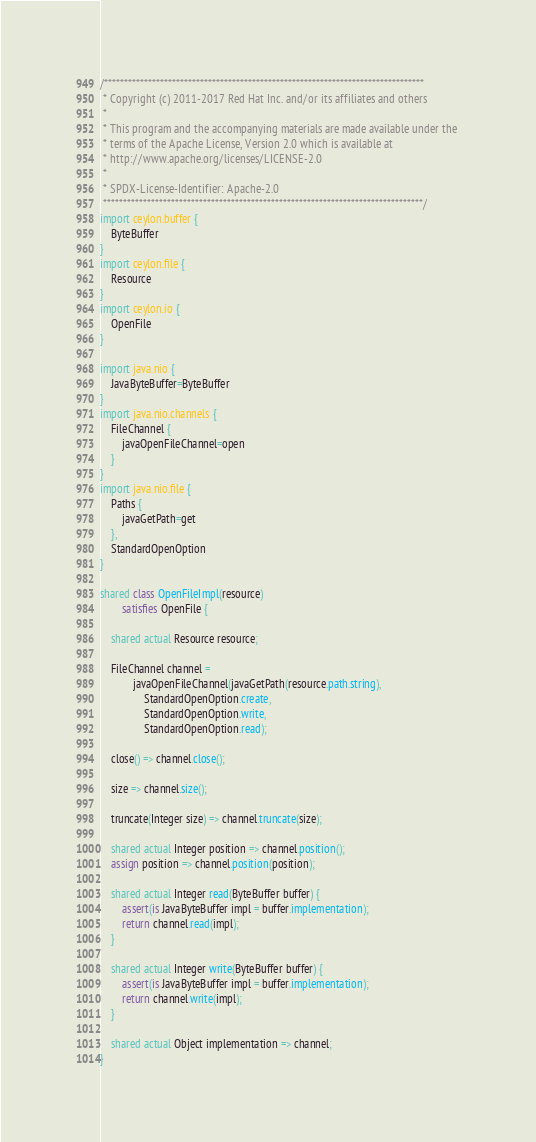<code> <loc_0><loc_0><loc_500><loc_500><_Ceylon_>/********************************************************************************
 * Copyright (c) 2011-2017 Red Hat Inc. and/or its affiliates and others
 *
 * This program and the accompanying materials are made available under the 
 * terms of the Apache License, Version 2.0 which is available at
 * http://www.apache.org/licenses/LICENSE-2.0
 *
 * SPDX-License-Identifier: Apache-2.0 
 ********************************************************************************/
import ceylon.buffer {
    ByteBuffer
}
import ceylon.file {
    Resource
}
import ceylon.io {
    OpenFile
}

import java.nio {
    JavaByteBuffer=ByteBuffer
}
import java.nio.channels {
    FileChannel {
        javaOpenFileChannel=open
    }
}
import java.nio.file {
    Paths {
        javaGetPath=get
    },
    StandardOpenOption
}

shared class OpenFileImpl(resource) 
        satisfies OpenFile {
    
    shared actual Resource resource;

	FileChannel channel = 
			javaOpenFileChannel(javaGetPath(resource.path.string),
                StandardOpenOption.create,
                StandardOpenOption.write,
                StandardOpenOption.read);
    
    close() => channel.close();

    size => channel.size();
    
    truncate(Integer size) => channel.truncate(size);
    
    shared actual Integer position => channel.position();
    assign position => channel.position(position);

    shared actual Integer read(ByteBuffer buffer) {
        assert(is JavaByteBuffer impl = buffer.implementation);
        return channel.read(impl);
    }

    shared actual Integer write(ByteBuffer buffer) {
        assert(is JavaByteBuffer impl = buffer.implementation);
        return channel.write(impl);
    }

    shared actual Object implementation => channel;
}</code> 